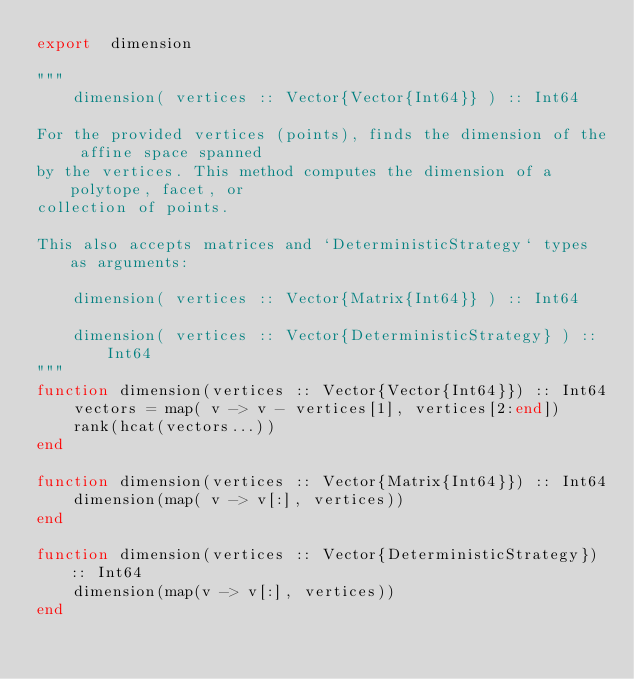<code> <loc_0><loc_0><loc_500><loc_500><_Julia_>export  dimension

"""
    dimension( vertices :: Vector{Vector{Int64}} ) :: Int64

For the provided vertices (points), finds the dimension of the affine space spanned
by the vertices. This method computes the dimension of a polytope, facet, or
collection of points.

This also accepts matrices and `DeterministicStrategy` types as arguments:

    dimension( vertices :: Vector{Matrix{Int64}} ) :: Int64

    dimension( vertices :: Vector{DeterministicStrategy} ) :: Int64
"""
function dimension(vertices :: Vector{Vector{Int64}}) :: Int64
    vectors = map( v -> v - vertices[1], vertices[2:end])
    rank(hcat(vectors...))
end

function dimension(vertices :: Vector{Matrix{Int64}}) :: Int64
    dimension(map( v -> v[:], vertices))
end

function dimension(vertices :: Vector{DeterministicStrategy}) :: Int64
    dimension(map(v -> v[:], vertices))
end
</code> 